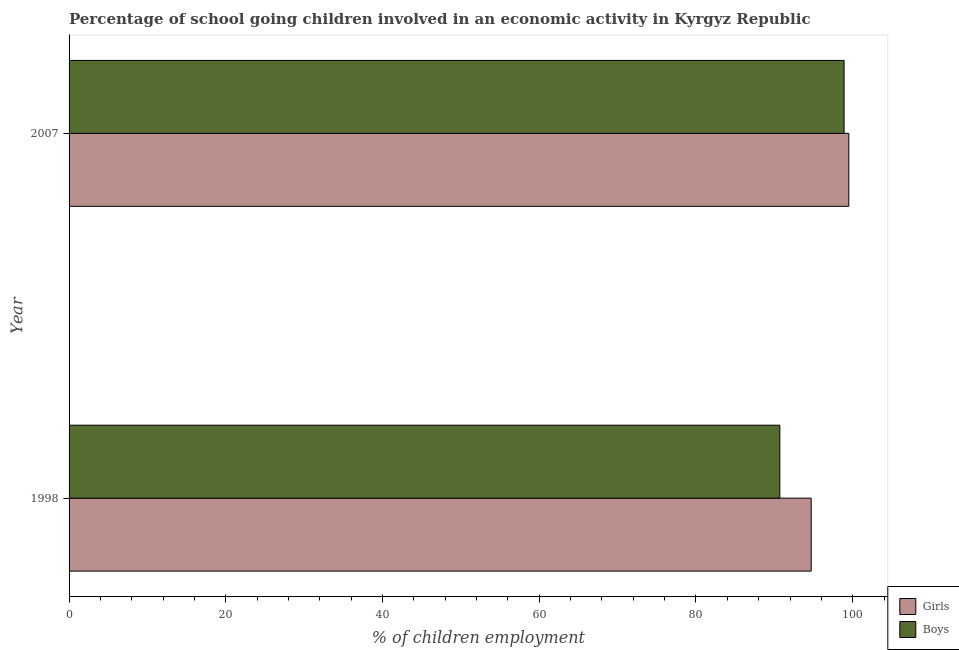How many different coloured bars are there?
Give a very brief answer. 2. How many groups of bars are there?
Offer a terse response. 2. Are the number of bars per tick equal to the number of legend labels?
Provide a short and direct response. Yes. How many bars are there on the 2nd tick from the bottom?
Provide a succinct answer. 2. What is the label of the 2nd group of bars from the top?
Ensure brevity in your answer.  1998. What is the percentage of school going boys in 2007?
Give a very brief answer. 98.9. Across all years, what is the maximum percentage of school going boys?
Your answer should be very brief. 98.9. Across all years, what is the minimum percentage of school going boys?
Give a very brief answer. 90.7. In which year was the percentage of school going girls maximum?
Offer a very short reply. 2007. What is the total percentage of school going girls in the graph?
Your answer should be compact. 194.2. What is the difference between the percentage of school going boys in 1998 and that in 2007?
Provide a succinct answer. -8.2. What is the difference between the percentage of school going boys in 1998 and the percentage of school going girls in 2007?
Give a very brief answer. -8.8. What is the average percentage of school going girls per year?
Your answer should be very brief. 97.1. In how many years, is the percentage of school going girls greater than the average percentage of school going girls taken over all years?
Give a very brief answer. 1. What does the 2nd bar from the top in 2007 represents?
Your response must be concise. Girls. What does the 2nd bar from the bottom in 2007 represents?
Your answer should be very brief. Boys. How many bars are there?
Make the answer very short. 4. How many years are there in the graph?
Keep it short and to the point. 2. What is the difference between two consecutive major ticks on the X-axis?
Your answer should be very brief. 20. Does the graph contain any zero values?
Make the answer very short. No. Does the graph contain grids?
Provide a short and direct response. No. How many legend labels are there?
Offer a very short reply. 2. What is the title of the graph?
Give a very brief answer. Percentage of school going children involved in an economic activity in Kyrgyz Republic. Does "Old" appear as one of the legend labels in the graph?
Keep it short and to the point. No. What is the label or title of the X-axis?
Offer a terse response. % of children employment. What is the % of children employment of Girls in 1998?
Keep it short and to the point. 94.7. What is the % of children employment in Boys in 1998?
Your answer should be very brief. 90.7. What is the % of children employment of Girls in 2007?
Keep it short and to the point. 99.5. What is the % of children employment in Boys in 2007?
Your answer should be compact. 98.9. Across all years, what is the maximum % of children employment in Girls?
Keep it short and to the point. 99.5. Across all years, what is the maximum % of children employment of Boys?
Your response must be concise. 98.9. Across all years, what is the minimum % of children employment of Girls?
Your answer should be very brief. 94.7. Across all years, what is the minimum % of children employment in Boys?
Your answer should be compact. 90.7. What is the total % of children employment in Girls in the graph?
Offer a terse response. 194.2. What is the total % of children employment in Boys in the graph?
Ensure brevity in your answer.  189.6. What is the difference between the % of children employment in Girls in 1998 and that in 2007?
Make the answer very short. -4.8. What is the difference between the % of children employment in Girls in 1998 and the % of children employment in Boys in 2007?
Keep it short and to the point. -4.2. What is the average % of children employment in Girls per year?
Provide a short and direct response. 97.1. What is the average % of children employment of Boys per year?
Your response must be concise. 94.8. In the year 2007, what is the difference between the % of children employment in Girls and % of children employment in Boys?
Give a very brief answer. 0.6. What is the ratio of the % of children employment of Girls in 1998 to that in 2007?
Offer a terse response. 0.95. What is the ratio of the % of children employment in Boys in 1998 to that in 2007?
Give a very brief answer. 0.92. What is the difference between the highest and the second highest % of children employment of Girls?
Your answer should be very brief. 4.8. What is the difference between the highest and the second highest % of children employment in Boys?
Your answer should be very brief. 8.2. 